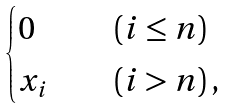<formula> <loc_0><loc_0><loc_500><loc_500>\begin{cases} 0 & \quad ( i \leq n ) \\ x _ { i } & \quad ( i > n ) \, , \end{cases}</formula> 